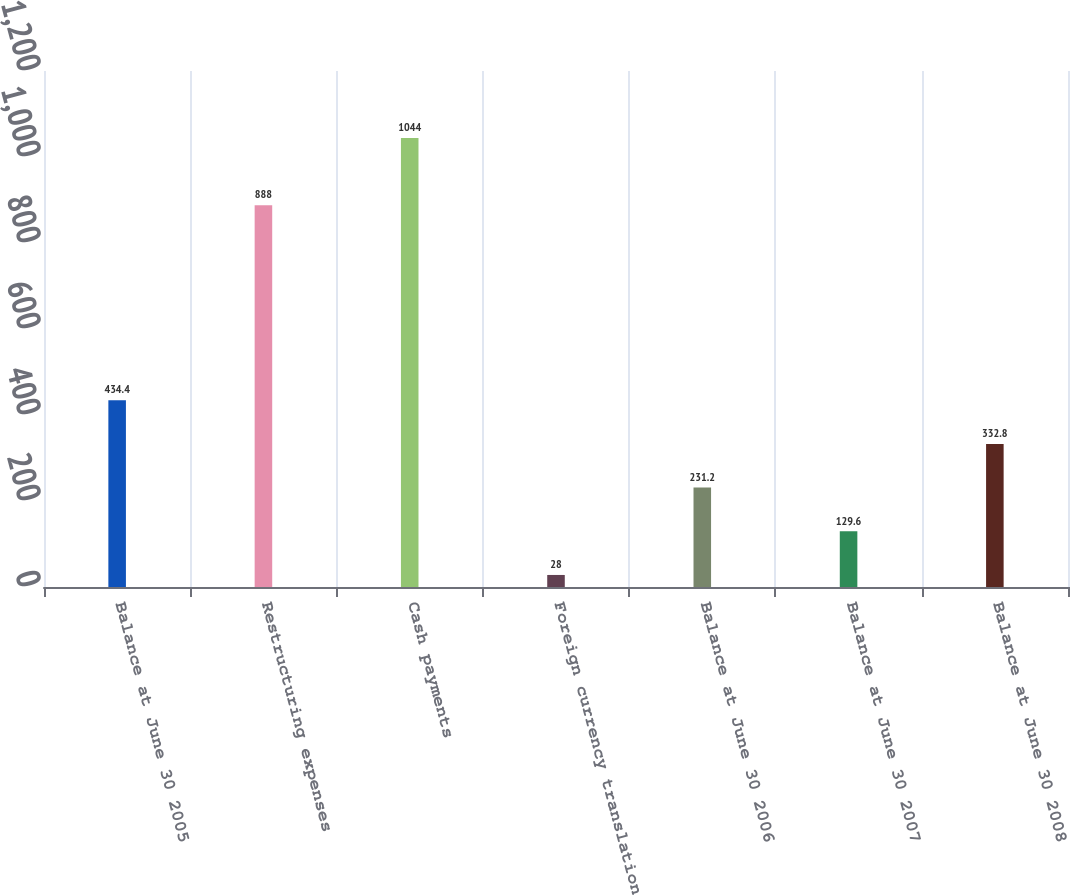Convert chart. <chart><loc_0><loc_0><loc_500><loc_500><bar_chart><fcel>Balance at June 30 2005<fcel>Restructuring expenses<fcel>Cash payments<fcel>Foreign currency translation<fcel>Balance at June 30 2006<fcel>Balance at June 30 2007<fcel>Balance at June 30 2008<nl><fcel>434.4<fcel>888<fcel>1044<fcel>28<fcel>231.2<fcel>129.6<fcel>332.8<nl></chart> 